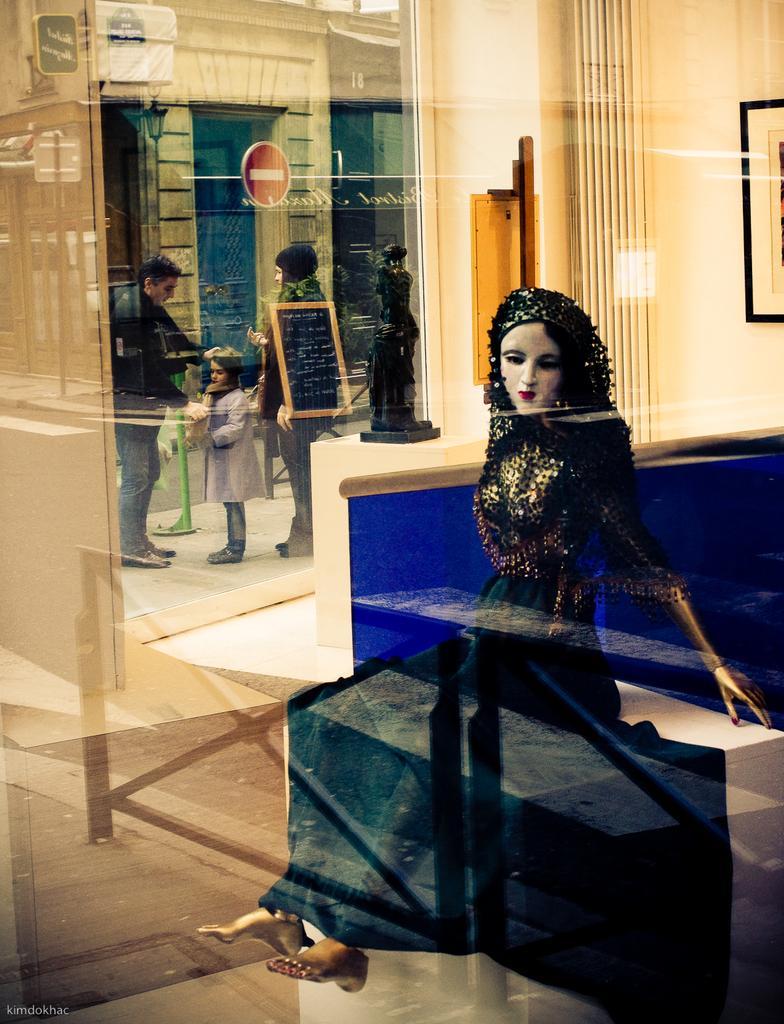Please provide a concise description of this image. In this image there is a sculpture, a statue on the stand, a photo frame attached to the wall in the building, there is a view from the window where there are a few people on the road, a building and a reflection on a board. 